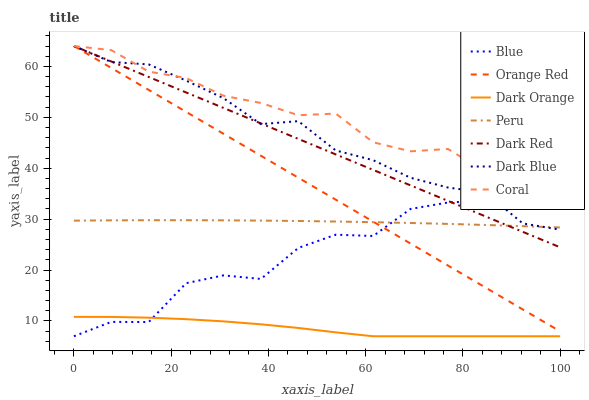Does Dark Orange have the minimum area under the curve?
Answer yes or no. Yes. Does Coral have the maximum area under the curve?
Answer yes or no. Yes. Does Dark Red have the minimum area under the curve?
Answer yes or no. No. Does Dark Red have the maximum area under the curve?
Answer yes or no. No. Is Dark Red the smoothest?
Answer yes or no. Yes. Is Blue the roughest?
Answer yes or no. Yes. Is Dark Orange the smoothest?
Answer yes or no. No. Is Dark Orange the roughest?
Answer yes or no. No. Does Dark Red have the lowest value?
Answer yes or no. No. Does Dark Orange have the highest value?
Answer yes or no. No. Is Dark Orange less than Coral?
Answer yes or no. Yes. Is Dark Blue greater than Dark Orange?
Answer yes or no. Yes. Does Dark Orange intersect Coral?
Answer yes or no. No. 